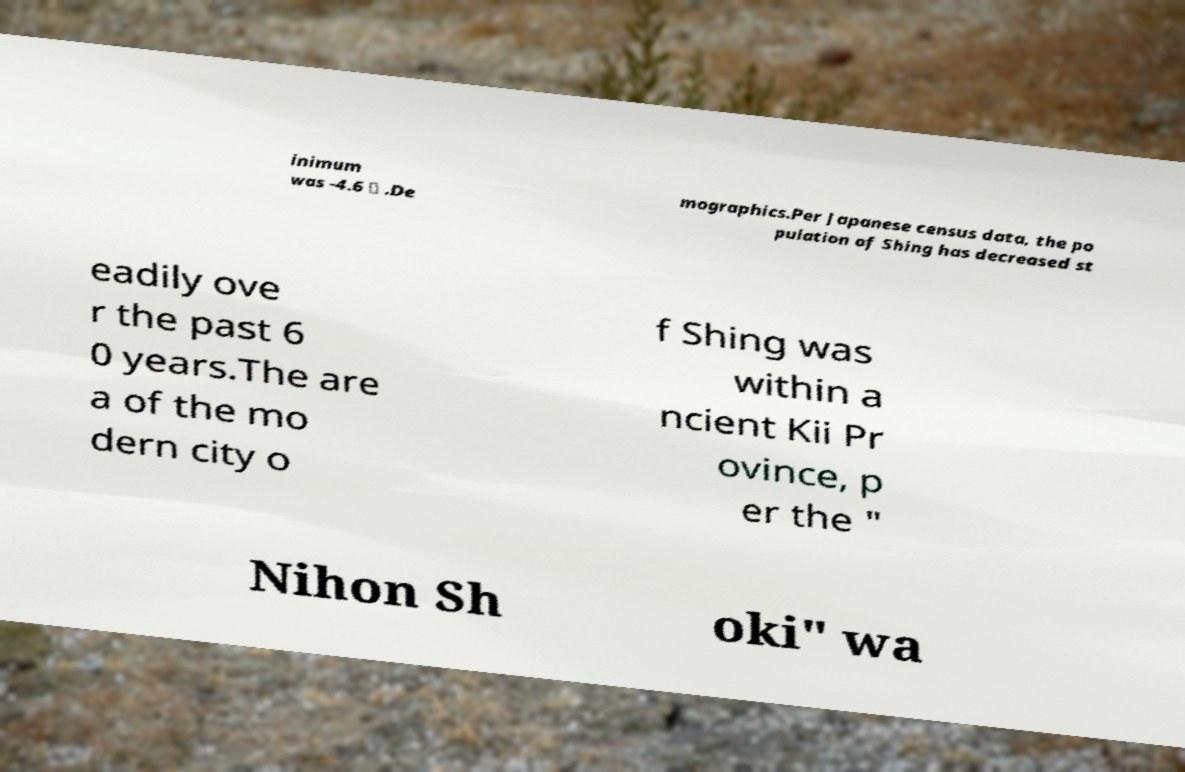Could you assist in decoding the text presented in this image and type it out clearly? inimum was -4.6 ℃ .De mographics.Per Japanese census data, the po pulation of Shing has decreased st eadily ove r the past 6 0 years.The are a of the mo dern city o f Shing was within a ncient Kii Pr ovince, p er the " Nihon Sh oki" wa 